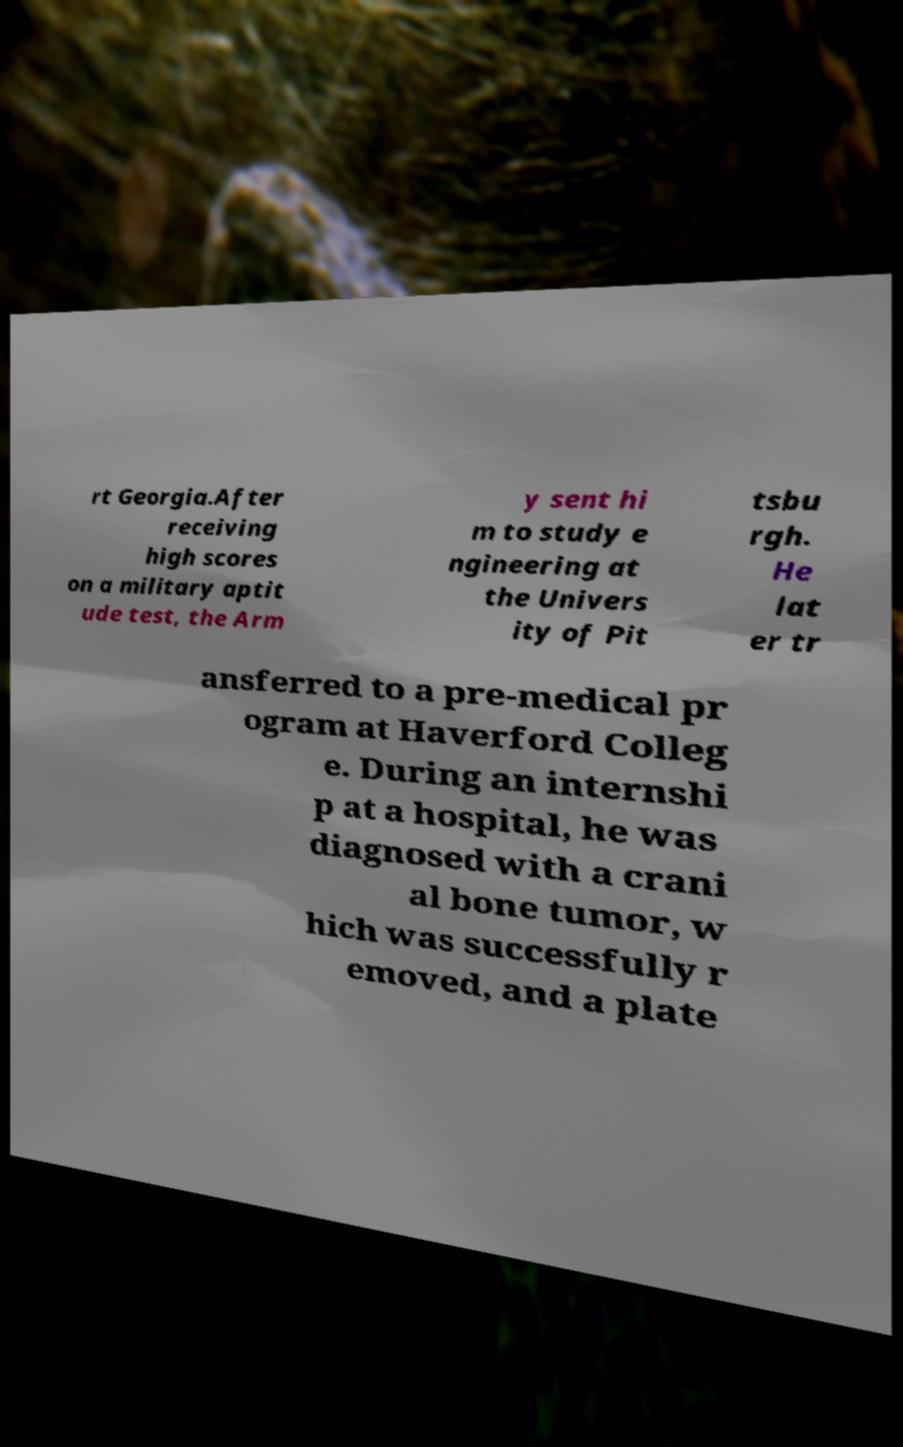I need the written content from this picture converted into text. Can you do that? rt Georgia.After receiving high scores on a military aptit ude test, the Arm y sent hi m to study e ngineering at the Univers ity of Pit tsbu rgh. He lat er tr ansferred to a pre-medical pr ogram at Haverford Colleg e. During an internshi p at a hospital, he was diagnosed with a crani al bone tumor, w hich was successfully r emoved, and a plate 